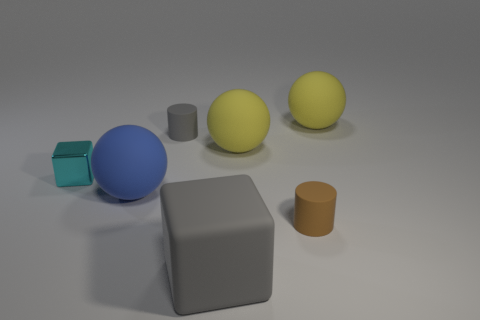Add 2 small gray cylinders. How many objects exist? 9 Subtract all cubes. How many objects are left? 5 Add 3 large gray cubes. How many large gray cubes are left? 4 Add 5 large blue rubber balls. How many large blue rubber balls exist? 6 Subtract 1 blue spheres. How many objects are left? 6 Subtract all big blocks. Subtract all matte balls. How many objects are left? 3 